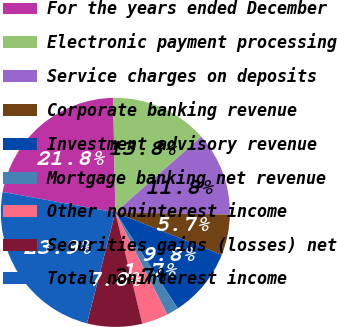Convert chart. <chart><loc_0><loc_0><loc_500><loc_500><pie_chart><fcel>For the years ended December<fcel>Electronic payment processing<fcel>Service charges on deposits<fcel>Corporate banking revenue<fcel>Investment advisory revenue<fcel>Mortgage banking net revenue<fcel>Other noninterest income<fcel>Securities gains (losses) net<fcel>Total noninterest income<nl><fcel>21.85%<fcel>13.82%<fcel>11.8%<fcel>5.73%<fcel>9.78%<fcel>1.69%<fcel>3.71%<fcel>7.76%<fcel>23.87%<nl></chart> 